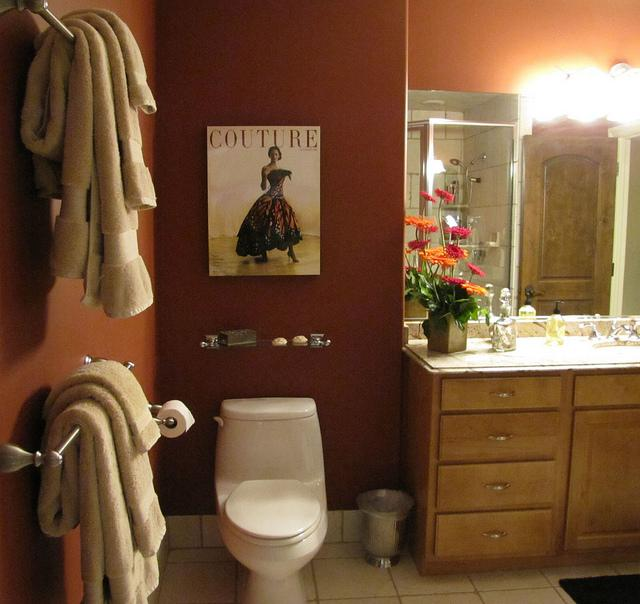What athlete's last name appears on the poster? Please explain your reasoning. randy couture. The last name couture is on the posture. though this was first, it shares the same with a pro football player. 